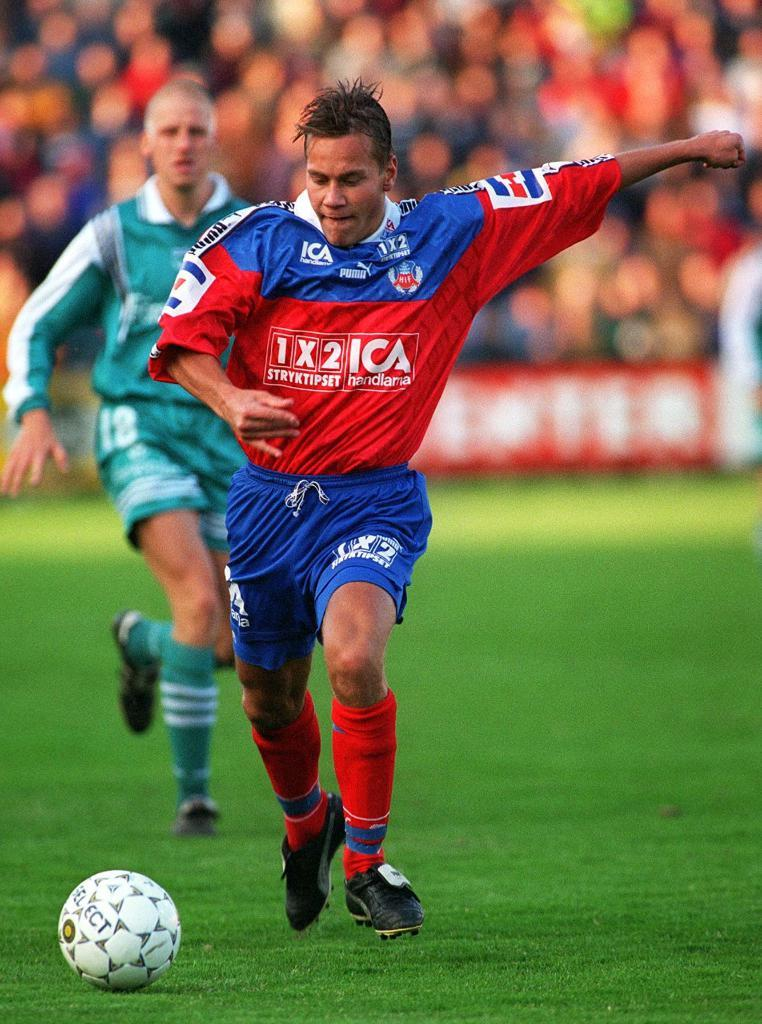<image>
Describe the image concisely. A soccer player in a red 1x2ica jersey goes to kick a ball with another player behind him. 